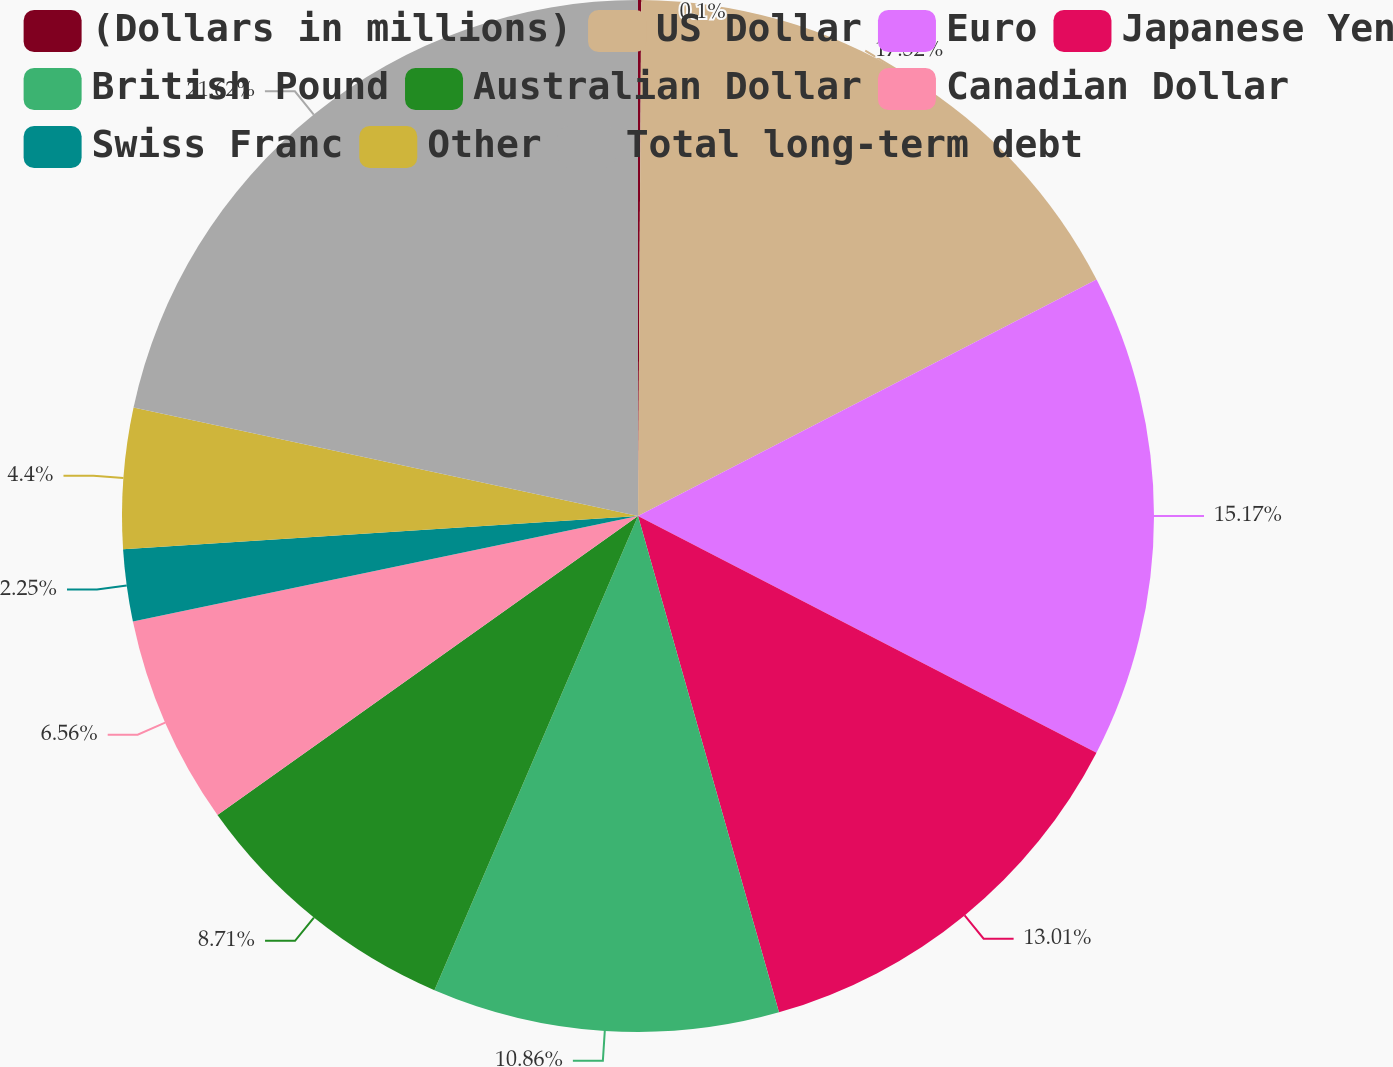<chart> <loc_0><loc_0><loc_500><loc_500><pie_chart><fcel>(Dollars in millions)<fcel>US Dollar<fcel>Euro<fcel>Japanese Yen<fcel>British Pound<fcel>Australian Dollar<fcel>Canadian Dollar<fcel>Swiss Franc<fcel>Other<fcel>Total long-term debt<nl><fcel>0.1%<fcel>17.32%<fcel>15.17%<fcel>13.01%<fcel>10.86%<fcel>8.71%<fcel>6.56%<fcel>2.25%<fcel>4.4%<fcel>21.63%<nl></chart> 